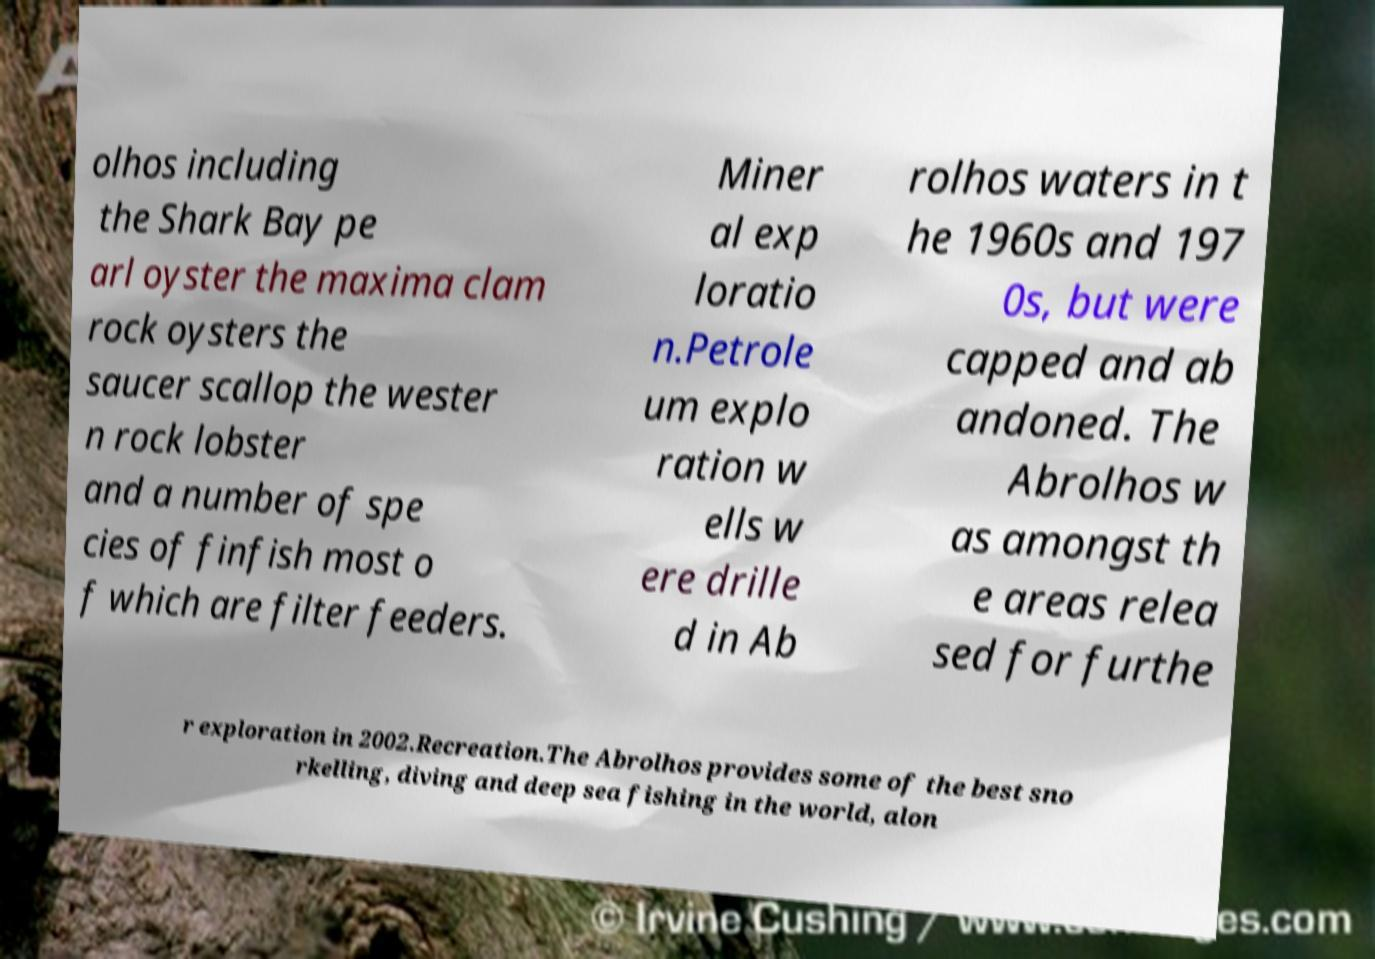I need the written content from this picture converted into text. Can you do that? olhos including the Shark Bay pe arl oyster the maxima clam rock oysters the saucer scallop the wester n rock lobster and a number of spe cies of finfish most o f which are filter feeders. Miner al exp loratio n.Petrole um explo ration w ells w ere drille d in Ab rolhos waters in t he 1960s and 197 0s, but were capped and ab andoned. The Abrolhos w as amongst th e areas relea sed for furthe r exploration in 2002.Recreation.The Abrolhos provides some of the best sno rkelling, diving and deep sea fishing in the world, alon 